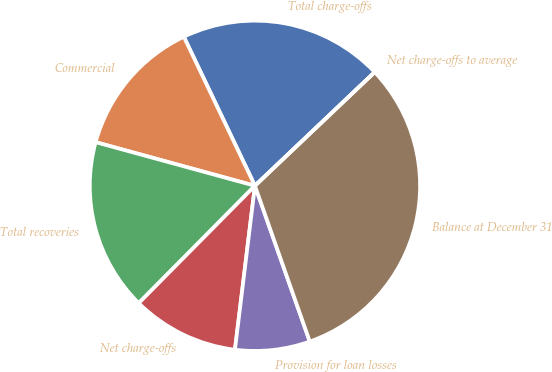Convert chart to OTSL. <chart><loc_0><loc_0><loc_500><loc_500><pie_chart><fcel>Total charge-offs<fcel>Commercial<fcel>Total recoveries<fcel>Net charge-offs<fcel>Provision for loan losses<fcel>Balance at December 31<fcel>Net charge-offs to average<nl><fcel>20.0%<fcel>13.66%<fcel>16.83%<fcel>10.49%<fcel>7.32%<fcel>31.69%<fcel>0.0%<nl></chart> 